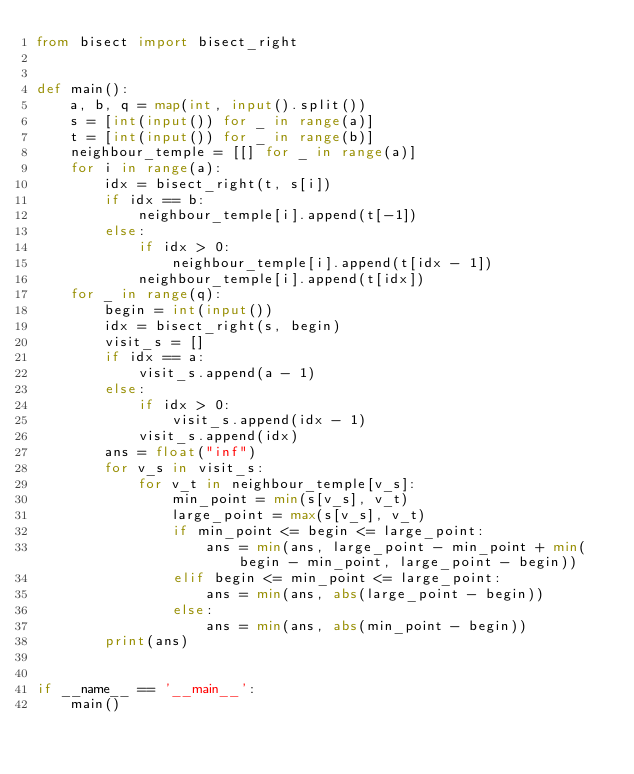<code> <loc_0><loc_0><loc_500><loc_500><_Python_>from bisect import bisect_right


def main():
    a, b, q = map(int, input().split())
    s = [int(input()) for _ in range(a)]
    t = [int(input()) for _ in range(b)]
    neighbour_temple = [[] for _ in range(a)]
    for i in range(a):
        idx = bisect_right(t, s[i])
        if idx == b:
            neighbour_temple[i].append(t[-1])
        else:
            if idx > 0:
                neighbour_temple[i].append(t[idx - 1])
            neighbour_temple[i].append(t[idx])
    for _ in range(q):
        begin = int(input())
        idx = bisect_right(s, begin)
        visit_s = []
        if idx == a:
            visit_s.append(a - 1)
        else:
            if idx > 0:
                visit_s.append(idx - 1)
            visit_s.append(idx)
        ans = float("inf")
        for v_s in visit_s:
            for v_t in neighbour_temple[v_s]:
                min_point = min(s[v_s], v_t)
                large_point = max(s[v_s], v_t)
                if min_point <= begin <= large_point:
                    ans = min(ans, large_point - min_point + min(begin - min_point, large_point - begin))
                elif begin <= min_point <= large_point:
                    ans = min(ans, abs(large_point - begin))
                else:
                    ans = min(ans, abs(min_point - begin))
        print(ans)


if __name__ == '__main__':
    main()
</code> 